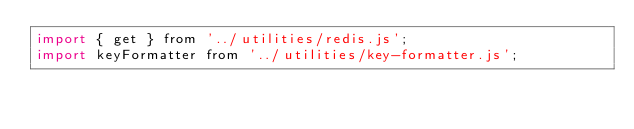<code> <loc_0><loc_0><loc_500><loc_500><_JavaScript_>import { get } from '../utilities/redis.js';
import keyFormatter from '../utilities/key-formatter.js';</code> 